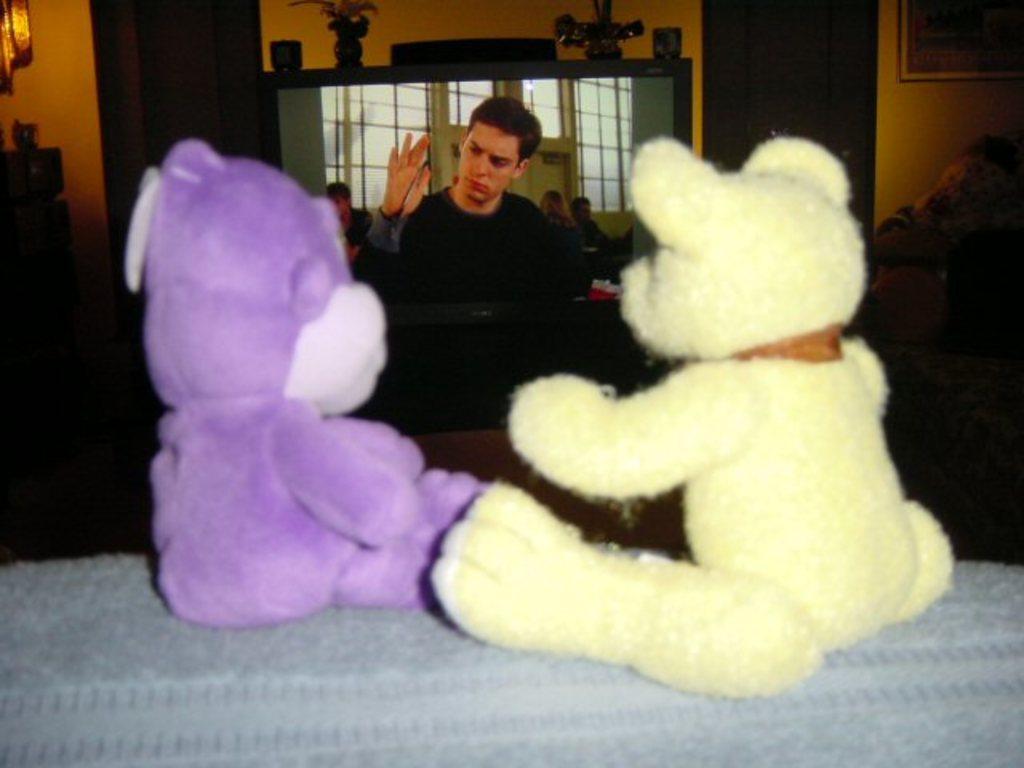Describe this image in one or two sentences. In this picture we can see there are two teddies on the cloth. In front of the teddies there is a television and on the television there are some objects. On the left and right side of the television there are some objects. Behind the television, there is a wall with a photo frame. 